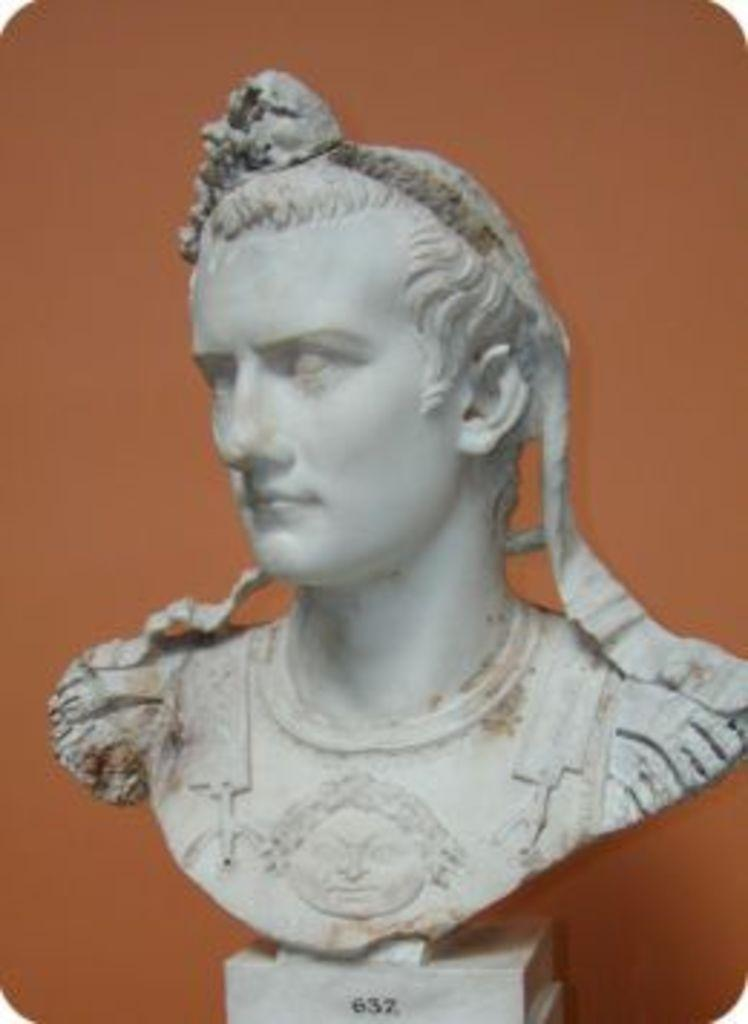What is the main subject in the foreground of the image? There is a sculpture in the foreground of the image. What color is the background of the image? The background of the image is brown. What is the name of the girl standing next to the sculpture in the image? There is no girl present in the image, only a sculpture in the foreground and a brown background. 